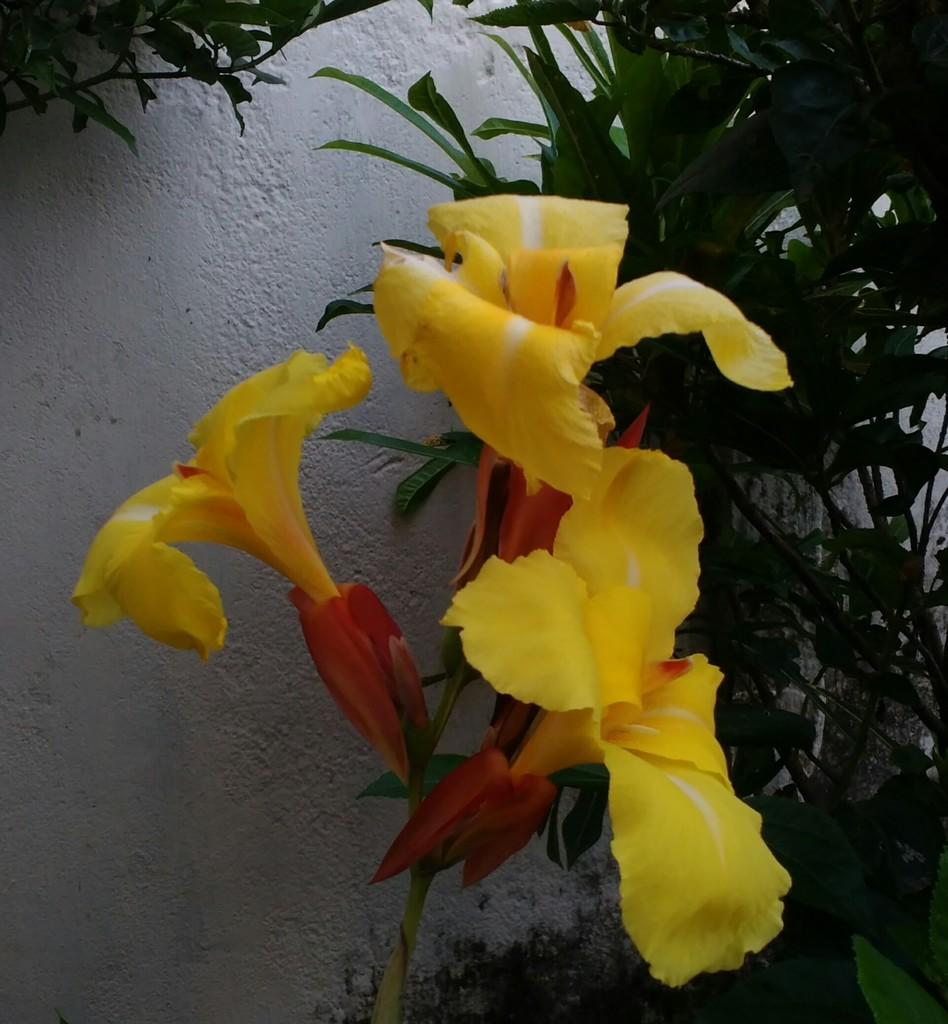What type of living organisms can be seen in the image? There are flowers and plants visible in the image. What is the background of the image? There is a wall visible behind the plants. What type of joke is being told by the flowers in the image? There is no joke being told by the flowers in the image, as they are plants and do not have the ability to tell jokes. 